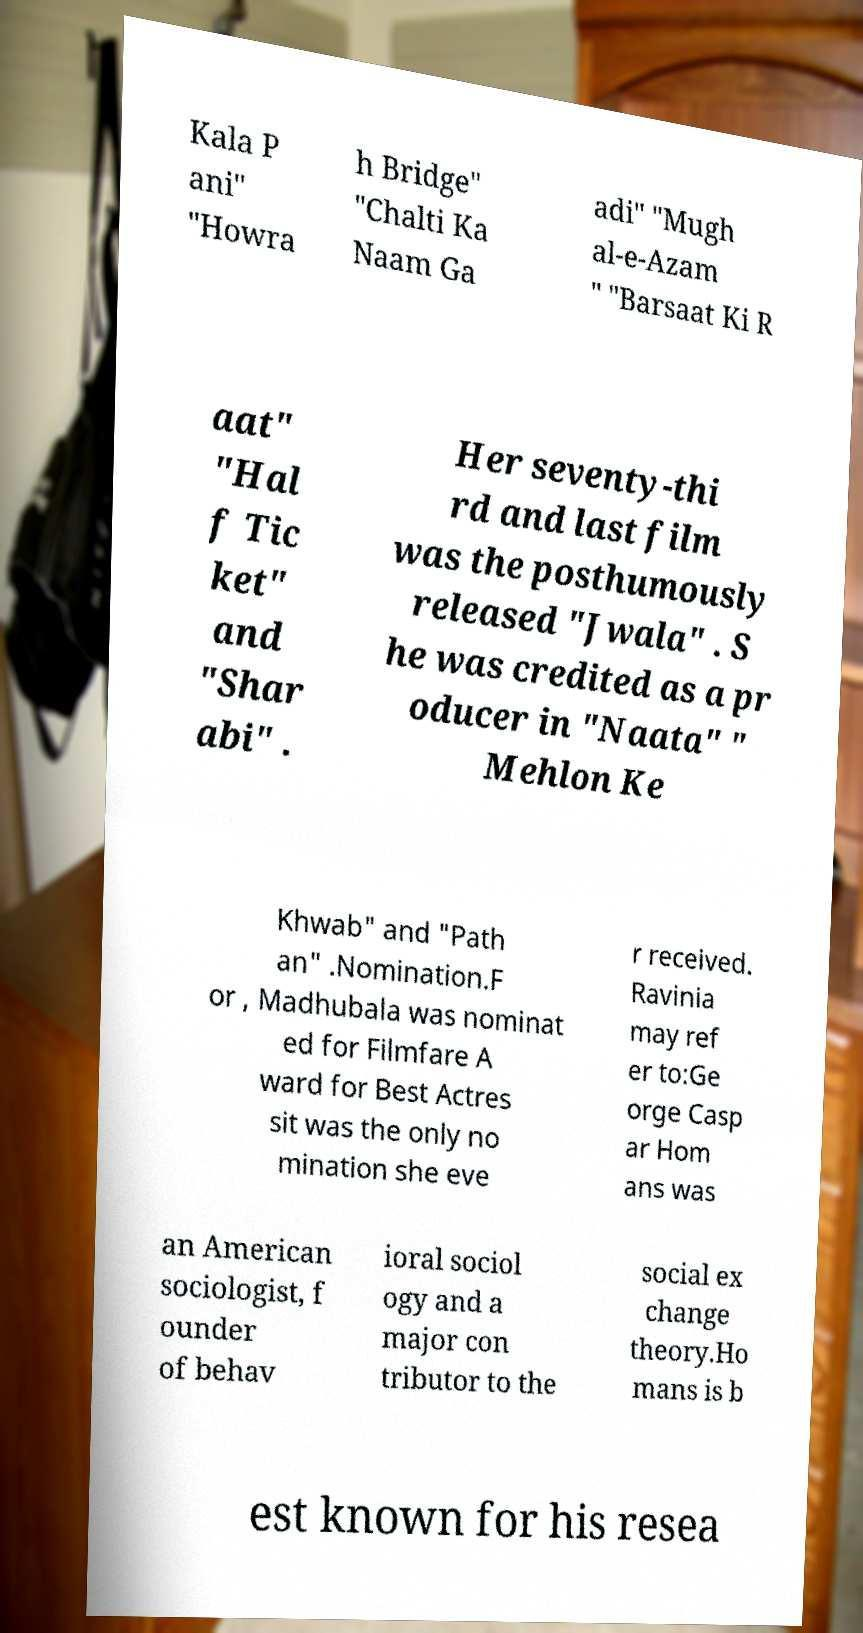Could you extract and type out the text from this image? Kala P ani" "Howra h Bridge" "Chalti Ka Naam Ga adi" "Mugh al-e-Azam " "Barsaat Ki R aat" "Hal f Tic ket" and "Shar abi" . Her seventy-thi rd and last film was the posthumously released "Jwala" . S he was credited as a pr oducer in "Naata" " Mehlon Ke Khwab" and "Path an" .Nomination.F or , Madhubala was nominat ed for Filmfare A ward for Best Actres sit was the only no mination she eve r received. Ravinia may ref er to:Ge orge Casp ar Hom ans was an American sociologist, f ounder of behav ioral sociol ogy and a major con tributor to the social ex change theory.Ho mans is b est known for his resea 